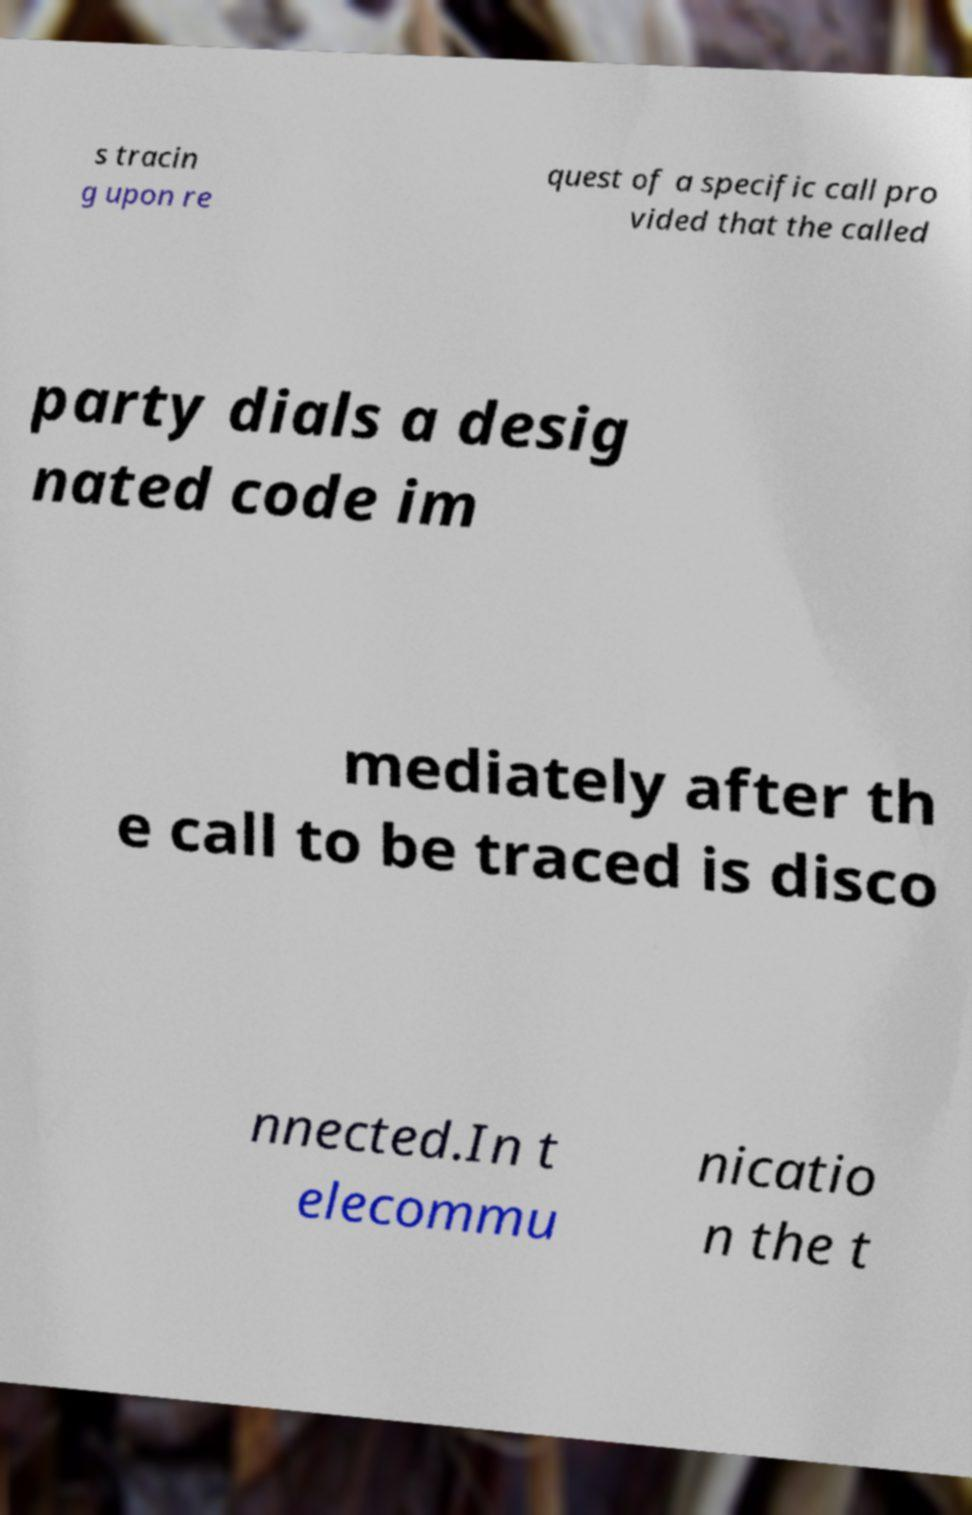Please identify and transcribe the text found in this image. s tracin g upon re quest of a specific call pro vided that the called party dials a desig nated code im mediately after th e call to be traced is disco nnected.In t elecommu nicatio n the t 